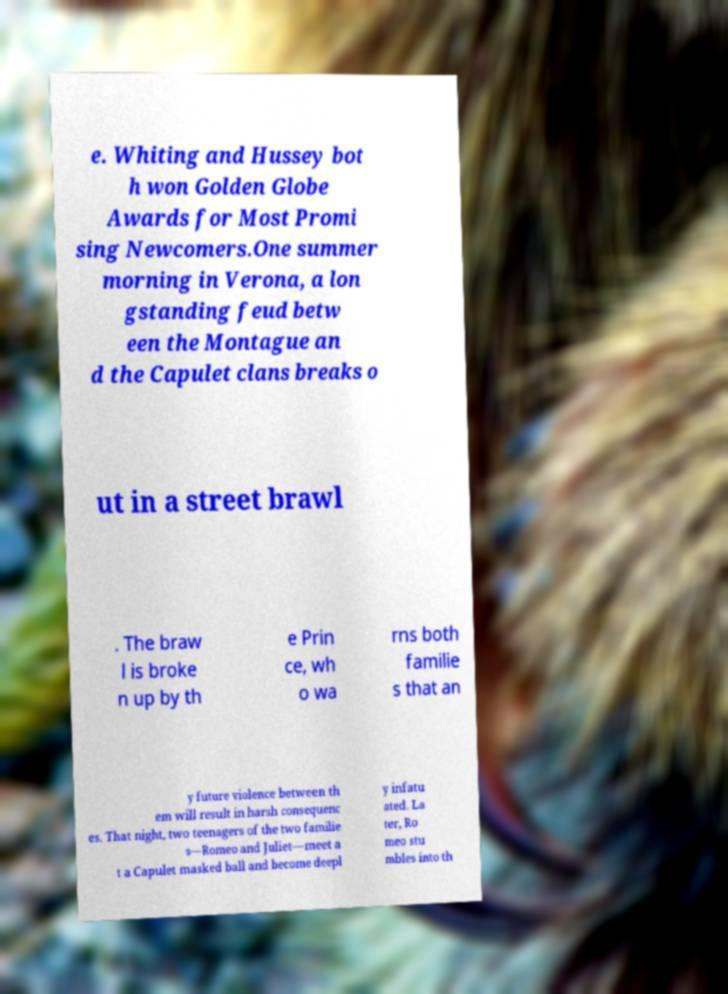Please read and relay the text visible in this image. What does it say? e. Whiting and Hussey bot h won Golden Globe Awards for Most Promi sing Newcomers.One summer morning in Verona, a lon gstanding feud betw een the Montague an d the Capulet clans breaks o ut in a street brawl . The braw l is broke n up by th e Prin ce, wh o wa rns both familie s that an y future violence between th em will result in harsh consequenc es. That night, two teenagers of the two familie s—Romeo and Juliet—meet a t a Capulet masked ball and become deepl y infatu ated. La ter, Ro meo stu mbles into th 